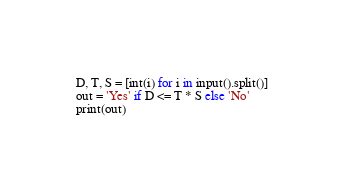Convert code to text. <code><loc_0><loc_0><loc_500><loc_500><_Python_>D, T, S = [int(i) for i in input().split()]
out = 'Yes' if D <= T * S else 'No'
print(out)
</code> 